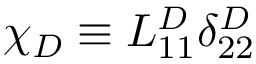Convert formula to latex. <formula><loc_0><loc_0><loc_500><loc_500>\chi _ { D } \equiv L _ { 1 1 } ^ { D } \delta _ { 2 2 } ^ { D }</formula> 